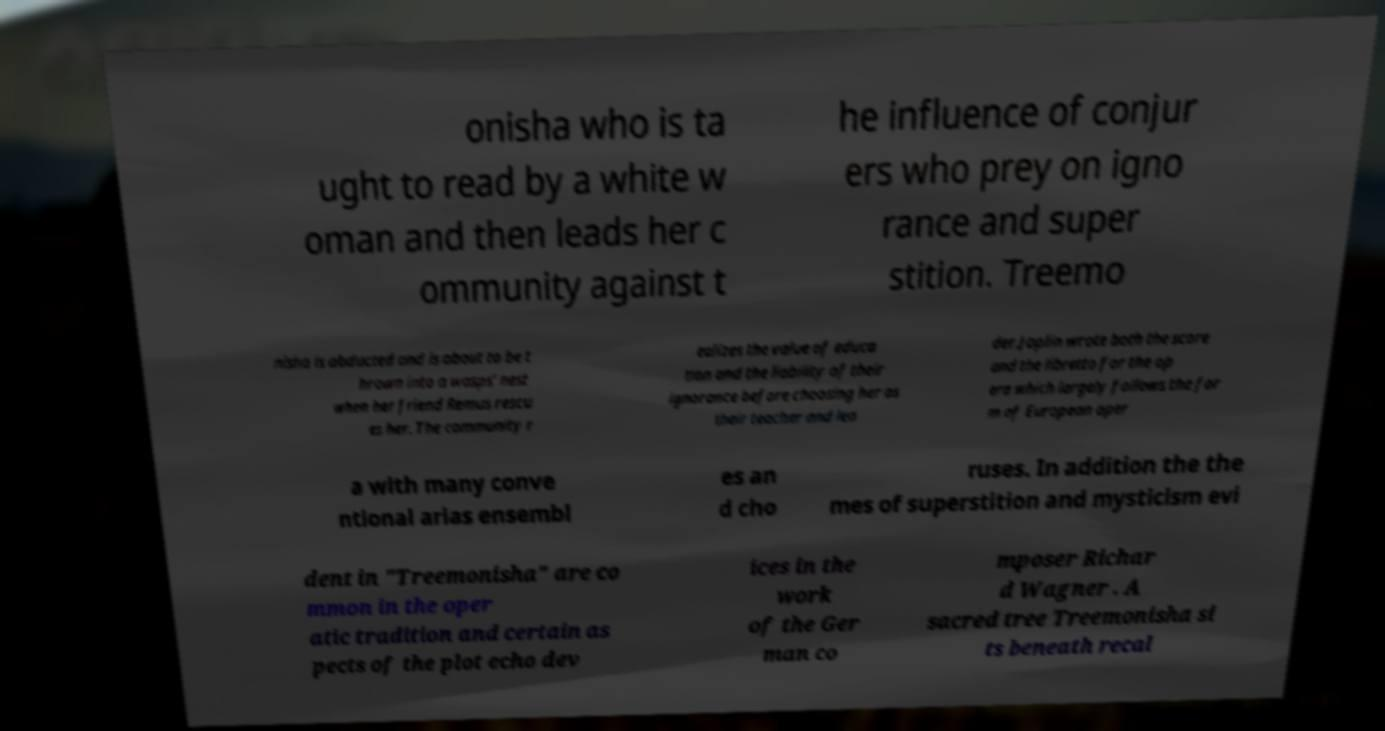There's text embedded in this image that I need extracted. Can you transcribe it verbatim? onisha who is ta ught to read by a white w oman and then leads her c ommunity against t he influence of conjur ers who prey on igno rance and super stition. Treemo nisha is abducted and is about to be t hrown into a wasps' nest when her friend Remus rescu es her. The community r ealizes the value of educa tion and the liability of their ignorance before choosing her as their teacher and lea der.Joplin wrote both the score and the libretto for the op era which largely follows the for m of European oper a with many conve ntional arias ensembl es an d cho ruses. In addition the the mes of superstition and mysticism evi dent in "Treemonisha" are co mmon in the oper atic tradition and certain as pects of the plot echo dev ices in the work of the Ger man co mposer Richar d Wagner . A sacred tree Treemonisha si ts beneath recal 